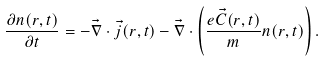<formula> <loc_0><loc_0><loc_500><loc_500>\frac { \partial n ( r , t ) } { \partial t } = - \vec { \nabla } \cdot \vec { j } ( r , t ) - \vec { \nabla } \cdot \left ( \frac { e \vec { C } ( r , t ) } { m } n ( r , t ) \right ) .</formula> 